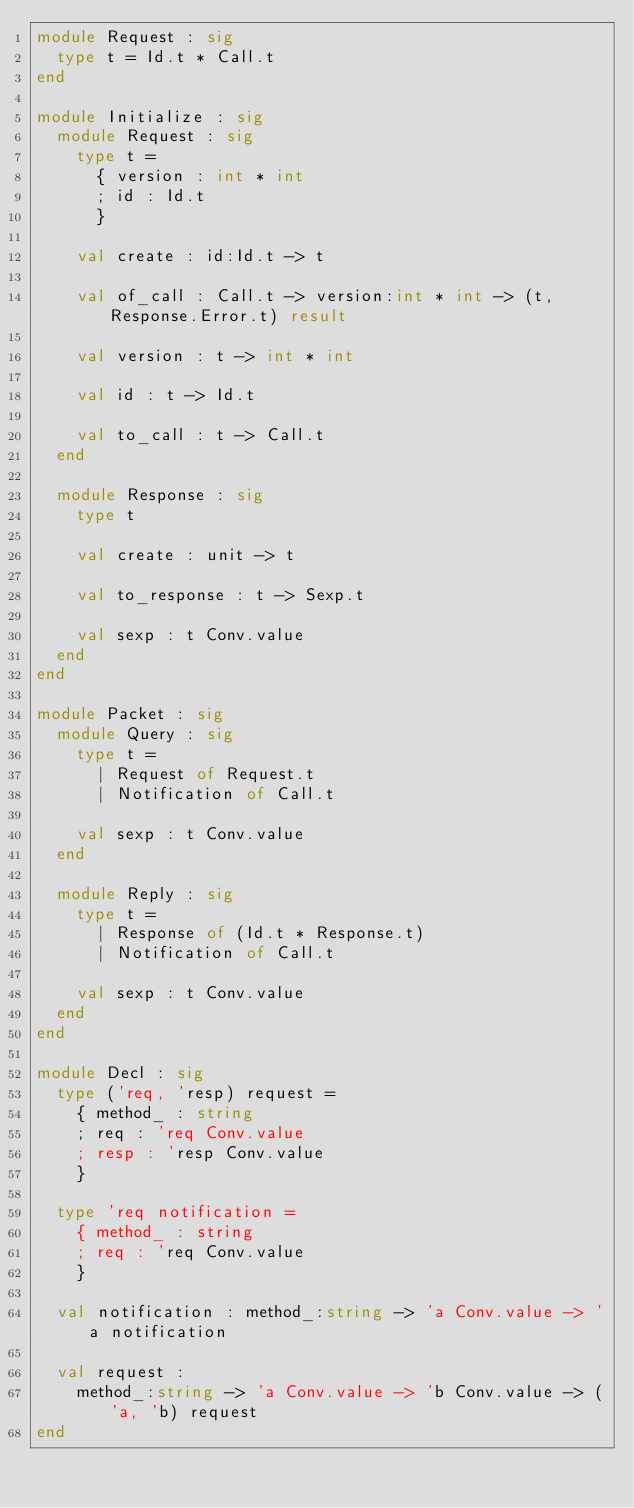<code> <loc_0><loc_0><loc_500><loc_500><_OCaml_>module Request : sig
  type t = Id.t * Call.t
end

module Initialize : sig
  module Request : sig
    type t =
      { version : int * int
      ; id : Id.t
      }

    val create : id:Id.t -> t

    val of_call : Call.t -> version:int * int -> (t, Response.Error.t) result

    val version : t -> int * int

    val id : t -> Id.t

    val to_call : t -> Call.t
  end

  module Response : sig
    type t

    val create : unit -> t

    val to_response : t -> Sexp.t

    val sexp : t Conv.value
  end
end

module Packet : sig
  module Query : sig
    type t =
      | Request of Request.t
      | Notification of Call.t

    val sexp : t Conv.value
  end

  module Reply : sig
    type t =
      | Response of (Id.t * Response.t)
      | Notification of Call.t

    val sexp : t Conv.value
  end
end

module Decl : sig
  type ('req, 'resp) request =
    { method_ : string
    ; req : 'req Conv.value
    ; resp : 'resp Conv.value
    }

  type 'req notification =
    { method_ : string
    ; req : 'req Conv.value
    }

  val notification : method_:string -> 'a Conv.value -> 'a notification

  val request :
    method_:string -> 'a Conv.value -> 'b Conv.value -> ('a, 'b) request
end
</code> 